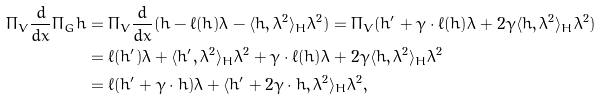Convert formula to latex. <formula><loc_0><loc_0><loc_500><loc_500>\Pi _ { V } \frac { d } { d x } \Pi _ { G } h & = \Pi _ { V } \frac { d } { d x } ( h - \ell ( h ) \lambda - \langle h , \lambda ^ { 2 } \rangle _ { H } \lambda ^ { 2 } ) = \Pi _ { V } ( h ^ { \prime } + \gamma \cdot \ell ( h ) \lambda + 2 \gamma \langle h , \lambda ^ { 2 } \rangle _ { H } \lambda ^ { 2 } ) \\ & = \ell ( h ^ { \prime } ) \lambda + \langle h ^ { \prime } , \lambda ^ { 2 } \rangle _ { H } \lambda ^ { 2 } + \gamma \cdot \ell ( h ) \lambda + 2 \gamma \langle h , \lambda ^ { 2 } \rangle _ { H } \lambda ^ { 2 } \\ & = \ell ( h ^ { \prime } + \gamma \cdot h ) \lambda + \langle h ^ { \prime } + 2 \gamma \cdot h , \lambda ^ { 2 } \rangle _ { H } \lambda ^ { 2 } ,</formula> 